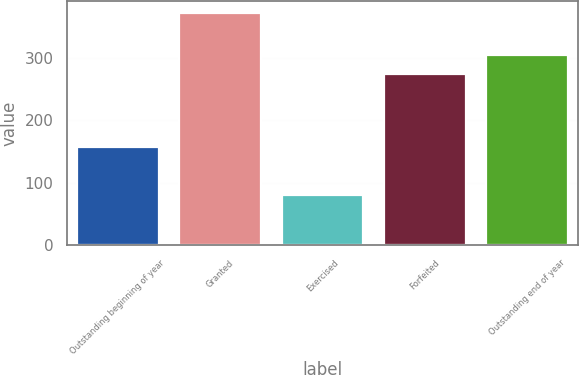Convert chart. <chart><loc_0><loc_0><loc_500><loc_500><bar_chart><fcel>Outstanding beginning of year<fcel>Granted<fcel>Exercised<fcel>Forfeited<fcel>Outstanding end of year<nl><fcel>157.07<fcel>371.7<fcel>80.31<fcel>274.25<fcel>303.39<nl></chart> 